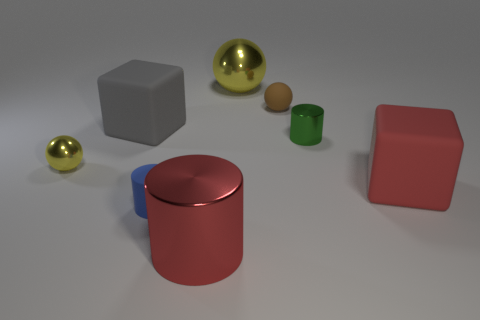How many yellow spheres must be subtracted to get 1 yellow spheres? 1 Add 1 big red cylinders. How many objects exist? 9 Subtract all cylinders. How many objects are left? 5 Add 1 large yellow cylinders. How many large yellow cylinders exist? 1 Subtract 0 blue blocks. How many objects are left? 8 Subtract all large red metallic objects. Subtract all matte things. How many objects are left? 3 Add 3 large cylinders. How many large cylinders are left? 4 